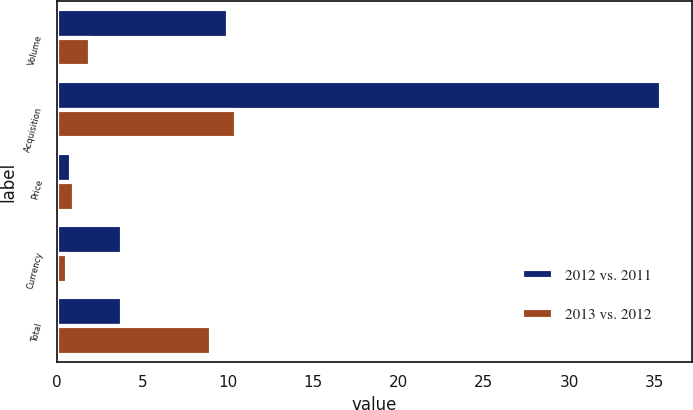Convert chart. <chart><loc_0><loc_0><loc_500><loc_500><stacked_bar_chart><ecel><fcel>Volume<fcel>Acquisition<fcel>Price<fcel>Currency<fcel>Total<nl><fcel>2012 vs. 2011<fcel>10<fcel>35.4<fcel>0.8<fcel>3.8<fcel>3.8<nl><fcel>2013 vs. 2012<fcel>1.9<fcel>10.5<fcel>1<fcel>0.6<fcel>9<nl></chart> 